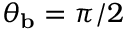Convert formula to latex. <formula><loc_0><loc_0><loc_500><loc_500>\theta _ { b } = \pi / 2</formula> 